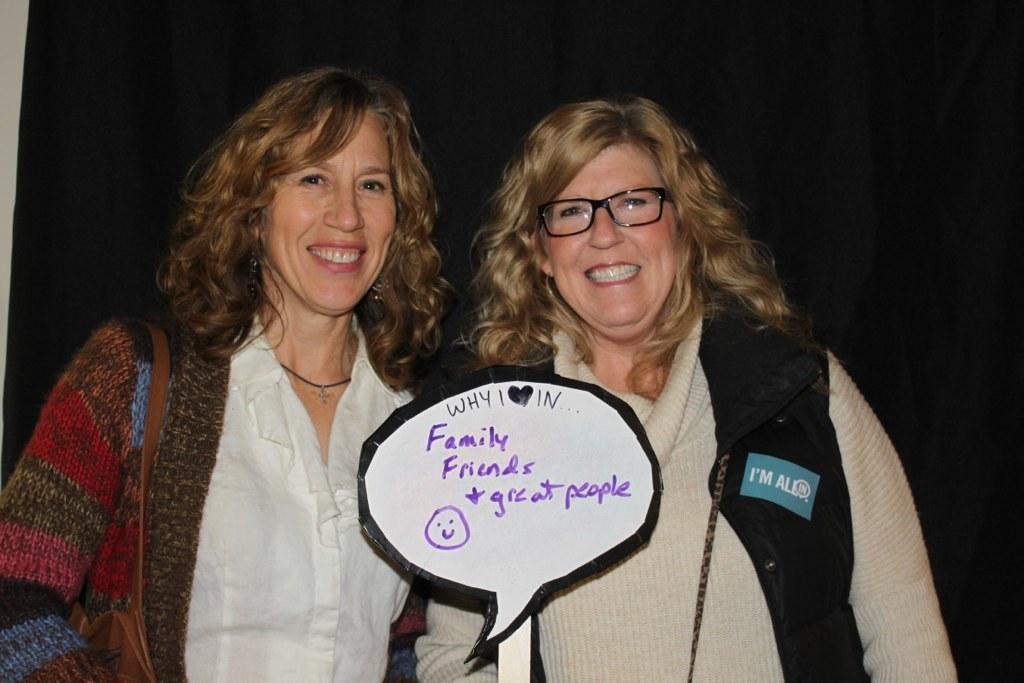Could you give a brief overview of what you see in this image? In this image there are two women standing and they are holding a board and they are smiling, one woman is wearing spectacles and there is black background. 